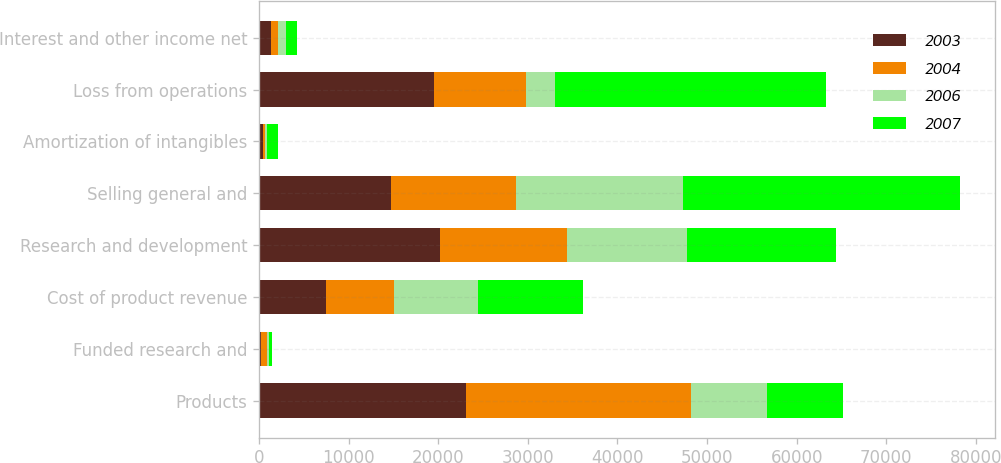<chart> <loc_0><loc_0><loc_500><loc_500><stacked_bar_chart><ecel><fcel>Products<fcel>Funded research and<fcel>Cost of product revenue<fcel>Research and development<fcel>Selling general and<fcel>Amortization of intangibles<fcel>Loss from operations<fcel>Interest and other income net<nl><fcel>2003<fcel>23127<fcel>183<fcel>7501<fcel>20206<fcel>14667<fcel>427<fcel>19491<fcel>1320<nl><fcel>2004<fcel>25070<fcel>669<fcel>7591<fcel>14150<fcel>14037<fcel>213<fcel>10252<fcel>806<nl><fcel>2006<fcel>8478.5<fcel>271<fcel>9366<fcel>13350<fcel>18566<fcel>187<fcel>3253<fcel>911<nl><fcel>2007<fcel>8478.5<fcel>348<fcel>11685<fcel>16739<fcel>30923<fcel>1308<fcel>30291<fcel>1198<nl></chart> 